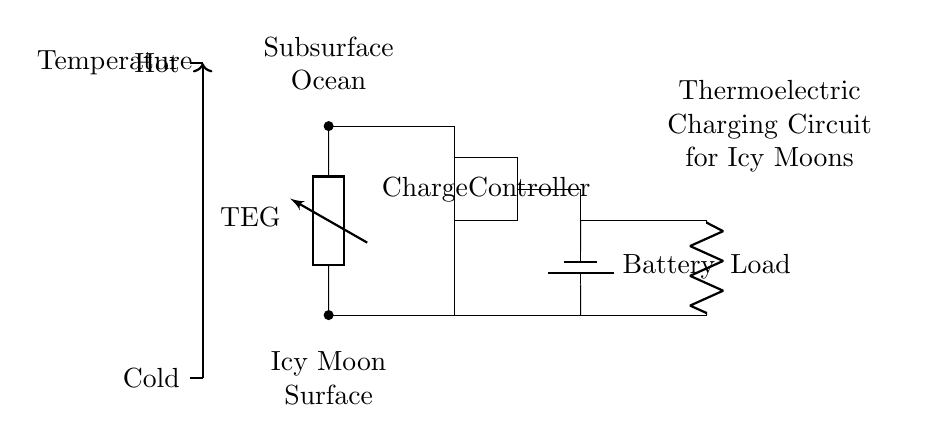What type of generator is used in this circuit? The circuit uses a thermoelectric generator, which is indicated by the label "TEG" in the diagram.
Answer: thermoelectric generator What provides power to the circuit? The battery, labeled "Battery" in the circuit, provides power to the circuit.
Answer: battery How many main components are involved in this circuit? The main components are the thermoelectric generator, battery, charge controller, and load, totaling four components.
Answer: four What does the charge controller do? The charge controller regulates the power flow from the thermoelectric generator to ensure safe charging and operation.
Answer: regulates power flow What temperature difference is represented in the circuit? The temperature gradient is indicated, with a cold temperature at the bottom and a hot temperature at the top of the diagram.
Answer: cold and hot How does the thermoelectric generator receive energy? The thermoelectric generator harnesses energy from the temperature gradient between the icy moon's surface and the subsurface ocean.
Answer: from temperature gradient Where is the load connected in the circuit? The load is connected to the right side of the circuit, indicated as "Load," and receives current from the battery and charge controller.
Answer: right side of circuit 